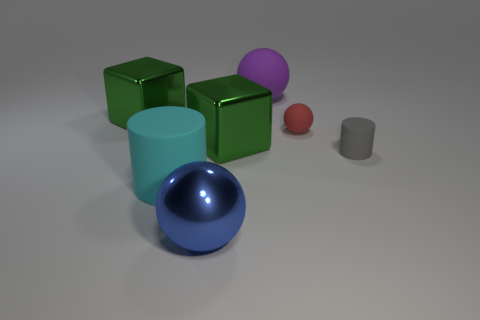How many objects are small rubber cylinders or objects that are on the left side of the gray object?
Your response must be concise. 7. Are there any blue balls made of the same material as the cyan thing?
Provide a succinct answer. No. There is a ball that is the same size as the blue metallic object; what material is it?
Your response must be concise. Rubber. There is a green block that is behind the matte ball in front of the purple ball; what is it made of?
Provide a succinct answer. Metal. Is the shape of the small rubber object that is left of the small gray rubber cylinder the same as  the big cyan object?
Your answer should be very brief. No. What color is the small cylinder that is made of the same material as the large cyan cylinder?
Your response must be concise. Gray. What material is the cylinder that is in front of the gray thing?
Offer a very short reply. Rubber. Do the purple object and the tiny matte thing that is behind the tiny gray rubber cylinder have the same shape?
Provide a short and direct response. Yes. There is a object that is behind the red matte sphere and to the left of the blue sphere; what material is it?
Provide a succinct answer. Metal. The other ball that is the same size as the blue metal ball is what color?
Your response must be concise. Purple. 